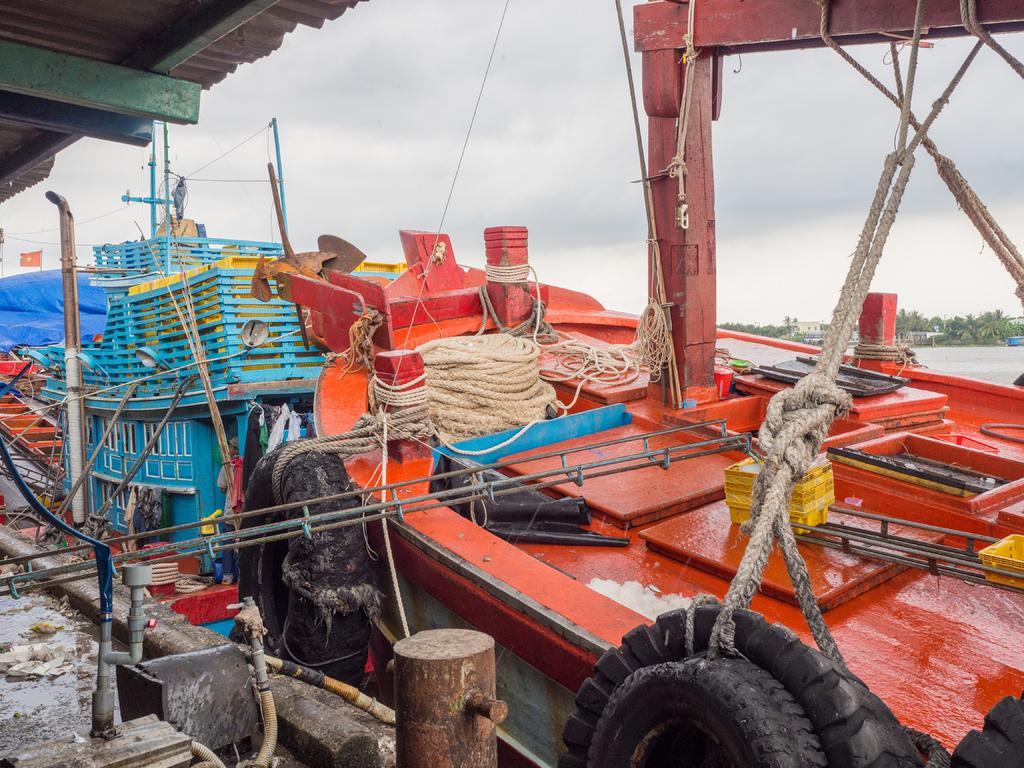Please provide a concise description of this image. In this image, I can see the boats with ropes, tyres and few other objects. At the top left side of the image, I can see a shed. On the right side of the image, I can see water and trees. In the background, there is the sky. 